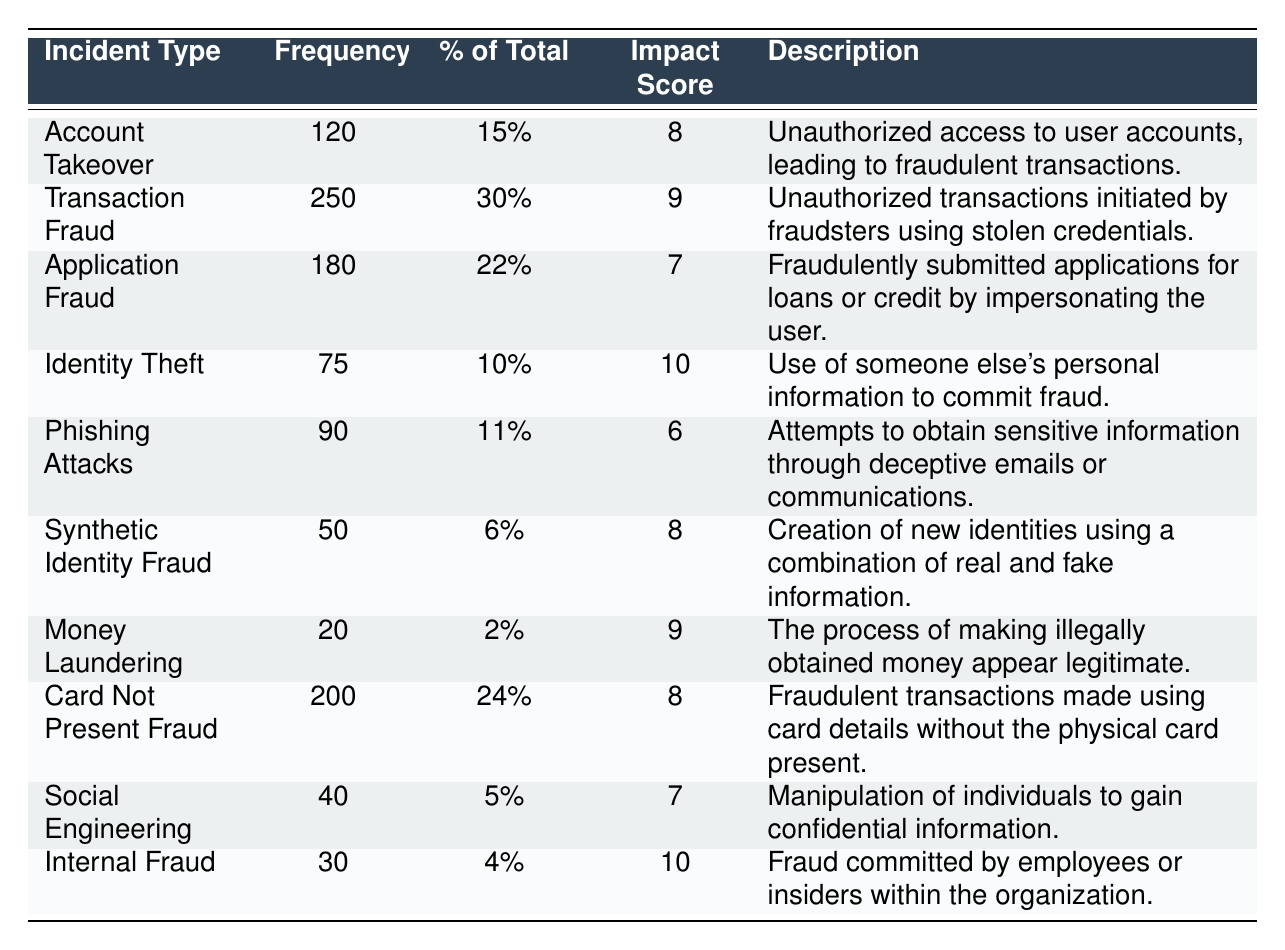What is the incident type with the highest frequency? The table indicates that "Transaction Fraud" has the highest frequency at 250 incidents.
Answer: Transaction Fraud What percentage of total incidents does "Identity Theft" represent? According to the table, "Identity Theft" represents 10% of the total incidents.
Answer: 10% Which incident type has the lowest frequency? Looking at the table, "Money Laundering" has the lowest frequency with only 20 incidents.
Answer: Money Laundering How many incidents are related to "Card Not Present Fraud" and "Application Fraud" combined? To find the combined frequency of "Card Not Present Fraud" and "Application Fraud": 200 + 180 = 380 incidents total.
Answer: 380 Is the impact score for "Synthetic Identity Fraud" greater than the impact score for "Phishing Attacks"? The impact score for "Synthetic Identity Fraud" is 8 and for "Phishing Attacks" it is 6, which makes this statement true.
Answer: Yes What is the total number of incidents reported in the table? Adding up all the frequencies: 120 + 250 + 180 + 75 + 90 + 50 + 20 + 200 + 40 + 30 = 1,155 incidents in total.
Answer: 1155 Which incident type has the highest impact score? The table shows that "Identity Theft" has the highest impact score of 10.
Answer: Identity Theft What is the average impact score of all incidents listed? The impact scores are 8, 9, 7, 10, 6, 8, 9, 8, 7, and 10, making the sum 82; with 10 incidents, the average is 82/10 = 8.2.
Answer: 8.2 Are there more incidents of "Social Engineering" than "Internal Fraud"? "Social Engineering" has 40 incidents while "Internal Fraud" only has 30; thus, there are more incidents of "Social Engineering".
Answer: Yes What is the frequency difference between "Transaction Fraud" and "Money Laundering"? The frequency of "Transaction Fraud" is 250 and "Money Laundering" is 20, leading to a difference of 250 - 20 = 230.
Answer: 230 